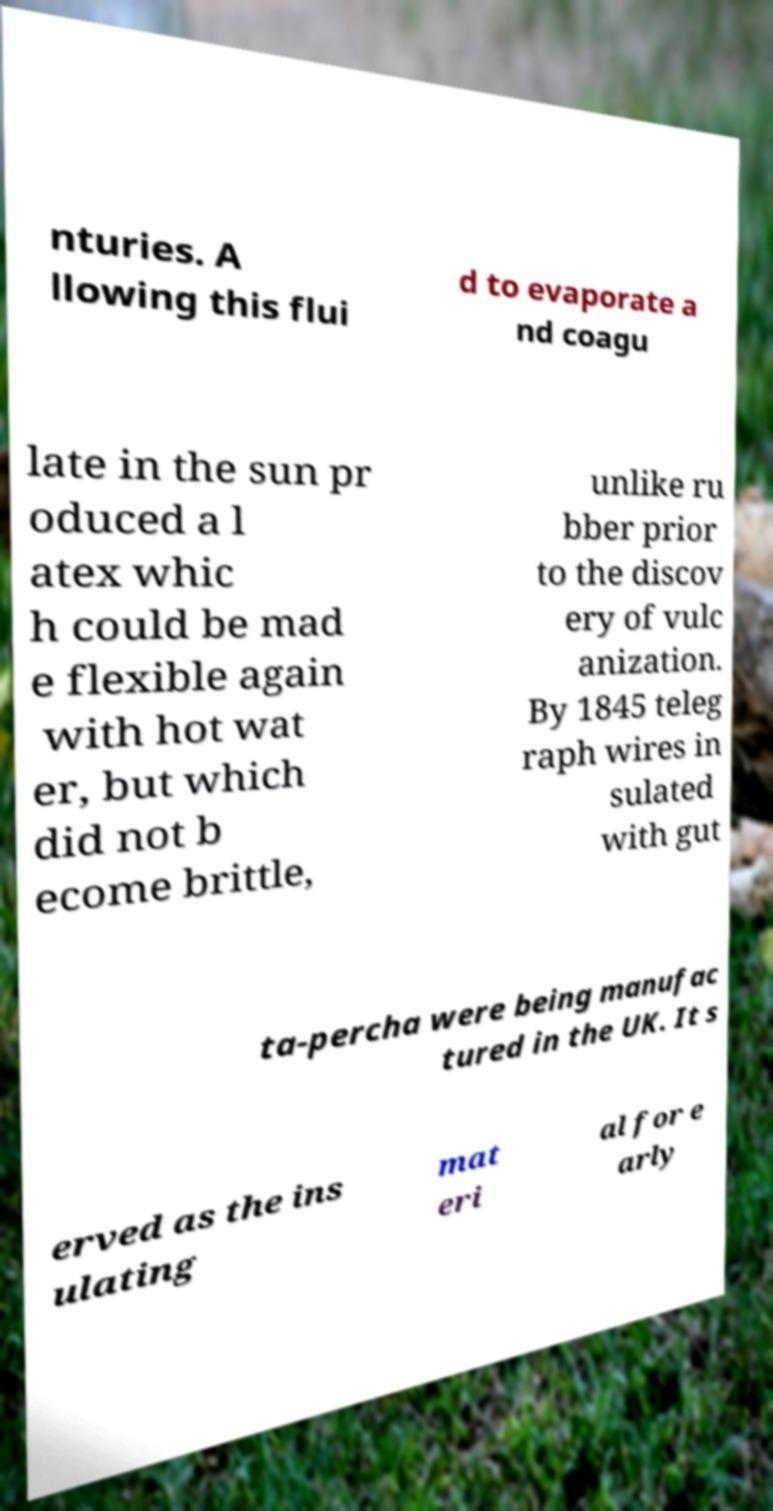Can you accurately transcribe the text from the provided image for me? nturies. A llowing this flui d to evaporate a nd coagu late in the sun pr oduced a l atex whic h could be mad e flexible again with hot wat er, but which did not b ecome brittle, unlike ru bber prior to the discov ery of vulc anization. By 1845 teleg raph wires in sulated with gut ta-percha were being manufac tured in the UK. It s erved as the ins ulating mat eri al for e arly 